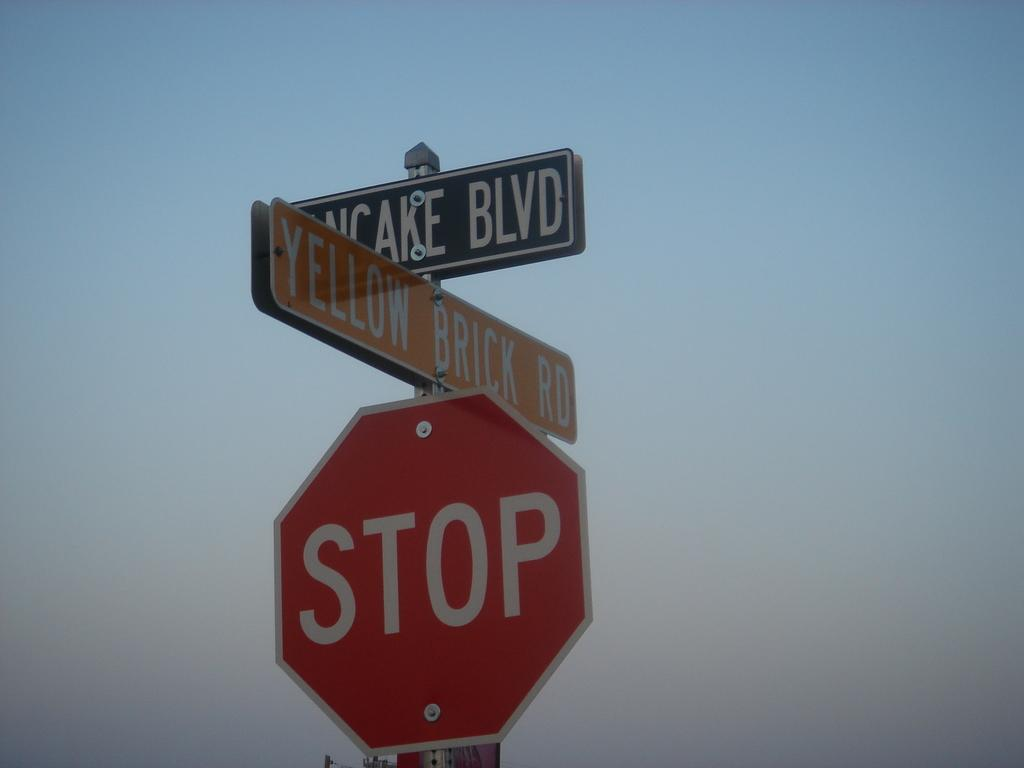<image>
Give a short and clear explanation of the subsequent image. Yellow sign on top of a red stop sign. 